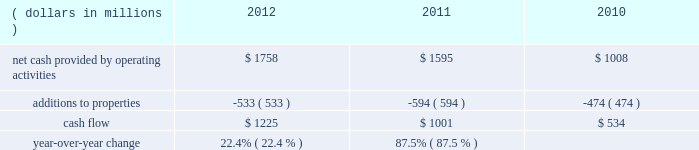We measure cash flow as net cash provided by operating activities reduced by expenditures for property additions .
We use this non-gaap financial measure of cash flow to focus management and investors on the amount of cash available for debt repayment , dividend distributions , acquisition opportunities , and share repurchases .
Our cash flow metric is reconciled to the most comparable gaap measure , as follows: .
Year-over-year change 22.4 % (  % ) 87.5 % (  % ) year-over-year changes in cash flow ( as defined ) were driven by improved performance in working capital resulting from the benefit derived from the pringles acquisition , as well as changes in the level of capital expenditures during the three-year period .
Investing activities our net cash used in investing activities for 2012 amounted to $ 3245 million , an increase of $ 2658 million compared with 2011 primarily attributable to the $ 2668 acquisition of pringles in capital spending in 2012 included investments in our supply chain infrastructure , and to support capacity requirements in certain markets , including pringles .
In addition , we continued the investment in our information technology infrastructure related to the reimplementation and upgrade of our sap platform .
Net cash used in investing activities of $ 587 million in 2011 increased by $ 122 million compared with 2010 , reflecting capital projects for our reimplementation and upgrade of our sap platform and investments in our supply chain .
Cash paid for additions to properties as a percentage of net sales has decreased to 3.8% ( 3.8 % ) in 2012 , from 4.5% ( 4.5 % ) in 2011 , which was an increase from 3.8% ( 3.8 % ) in financing activities in february 2013 , we issued $ 250 million of two-year floating-rate u.s .
Dollar notes , and $ 400 million of ten-year 2.75% ( 2.75 % ) u.s .
Dollar notes .
The proceeds from these notes will be used for general corporate purposes , including , together with cash on hand , repayment of the $ 750 million aggregate principal amount of our 4.25% ( 4.25 % ) u.s .
Dollar notes due march 2013 .
The floating-rate notes bear interest equal to three-month libor plus 23 basis points , subject to quarterly reset .
The notes contain customary covenants that limit the ability of kellogg company and its restricted subsidiaries ( as defined ) to incur certain liens or enter into certain sale and lease-back transactions , as well as a change of control provision .
Our net cash provided by financing activities was $ 1317 for 2012 , compared to net cash used in financing activities of $ 957 and $ 439 for 2011 and 2010 , respectively .
The increase in cash provided from financing activities in 2012 compared to 2011 and 2010 , was primarily due to the issuance of debt related to the acquisition of pringles .
Total debt was $ 7.9 billion at year-end 2012 and $ 6.0 billion at year-end 2011 .
In march 2012 , we entered into interest rate swaps on our $ 500 million five-year 1.875% ( 1.875 % ) fixed rate u.s .
Dollar notes due 2016 , $ 500 million ten-year 4.15% ( 4.15 % ) fixed rate u.s .
Dollar notes due 2019 and $ 500 million of our $ 750 million seven-year 4.45% ( 4.45 % ) fixed rate u.s .
Dollar notes due 2016 .
The interest rate swaps effectively converted these notes from their fixed rates to floating rate obligations through maturity .
In may 2012 , we issued $ 350 million of three-year 1.125% ( 1.125 % ) u.s .
Dollar notes , $ 400 million of five-year 1.75% ( 1.75 % ) u.s .
Dollar notes and $ 700 million of ten-year 3.125% ( 3.125 % ) u.s .
Dollar notes , resulting in aggregate net proceeds after debt discount of $ 1.442 billion .
The proceeds of these notes were used for general corporate purposes , including financing a portion of the acquisition of pringles .
In may 2012 , we issued cdn .
$ 300 million of two-year 2.10% ( 2.10 % ) fixed rate canadian dollar notes , using the proceeds from these notes for general corporate purposes , which included repayment of intercompany debt .
This repayment resulted in cash available to be used for a portion of the acquisition of pringles .
In december 2012 , we repaid $ 750 million five-year 5.125% ( 5.125 % ) u.s .
Dollar notes at maturity with commercial paper .
In february 2011 , we entered into interest rate swaps on $ 200 million of our $ 750 million seven-year 4.45% ( 4.45 % ) fixed rate u.s .
Dollar notes due 2016 .
The interest rate swaps effectively converted this portion of the notes from a fixed rate to a floating rate obligation through maturity .
In april 2011 , we repaid $ 945 million ten-year 6.60% ( 6.60 % ) u.s .
Dollar notes at maturity with commercial paper .
In may 2011 , we issued $ 400 million of seven-year 3.25% ( 3.25 % ) fixed rate u.s .
Dollar notes , using the proceeds of $ 397 million for general corporate purposes and repayment of commercial paper .
During 2011 , we entered into interest rate swaps with notional amounts totaling $ 400 million , which effectively converted these notes from a fixed rate to a floating rate obligation through maturity .
In november 2011 , we issued $ 500 million of five-year 1.875% ( 1.875 % ) fixed rate u .
Dollar notes , using the proceeds of $ 498 million for general corporate purposes and repayment of commercial paper .
During 2012 , we entered into interest rate swaps which effectively converted these notes from a fixed rate to a floating rate obligation through maturity .
In april 2010 , our board of directors approved a share repurchase program authorizing us to repurchase shares of our common stock amounting to $ 2.5 billion during 2010 through 2012 .
This three year authorization replaced previous share buyback programs which had authorized stock repurchases of up to $ 1.1 billion for 2010 and $ 650 million for 2009 .
Under this program , we repurchased approximately 1 million , 15 million and 21 million shares of common stock for $ 63 million , $ 793 million and $ 1.1 billion during 2012 , 2011 and 2010 , respectively .
In december 2012 , our board of directors approved a share repurchase program authorizing us to repurchase shares of our common stock amounting to $ 300 million during 2013 .
We paid quarterly dividends to shareholders totaling $ 1.74 per share in 2012 , $ 1.67 per share in 2011 and $ 1.56 per share in 2010 .
Total cash paid for dividends increased by 3.0% ( 3.0 % ) in 2012 and 3.4% ( 3.4 % ) in 2011 .
In march 2011 , we entered into an unsecured four- year credit agreement which allows us to borrow , on a revolving credit basis , up to $ 2.0 billion .
Our long-term debt agreements contain customary covenants that limit kellogg company and some of its subsidiaries from incurring certain liens or from entering into certain sale and lease-back transactions .
Some agreements also contain change in control provisions .
However , they do not contain acceleration of maturity clauses that are dependent on credit ratings .
A change in our credit ratings could limit our access to the u.s .
Short-term debt market and/or increase the cost of refinancing long-term debt in the future .
However , even under these circumstances , we would continue to have access to our four-year credit agreement , which expires in march 2015 .
This source of liquidity is unused and available on an unsecured basis , although we do not currently plan to use it .
Capital and credit markets , including commercial paper markets , continued to experience instability and disruption as the u.s .
And global economies underwent a period of extreme uncertainty .
Throughout this period of uncertainty , we continued to have access to the u.s. , european , and canadian commercial paper markets .
Our commercial paper and term debt credit ratings were not affected by the changes in the credit environment .
We monitor the financial strength of our third-party financial institutions , including those that hold our cash and cash equivalents as well as those who serve as counterparties to our credit facilities , our derivative financial instruments , and other arrangements .
We are in compliance with all covenants as of december 29 , 2012 .
We continue to believe that we will be able to meet our interest and principal repayment obligations and maintain our debt covenants for the foreseeable future , while still meeting our operational needs , including the pursuit of selected bolt-on acquisitions .
This will be accomplished through our strong cash flow , our short- term borrowings , and our maintenance of credit facilities on a global basis. .
What percent increase in net cash from investing activities occurred between 2011 and 2012? 
Rationale: subtracting the old value by the new value eliminates the need to subtract 1 at the end . both work , but in this case it made more sense to do it this way .
Computations: (2658 / (3245 - 2658))
Answer: 4.52811. 